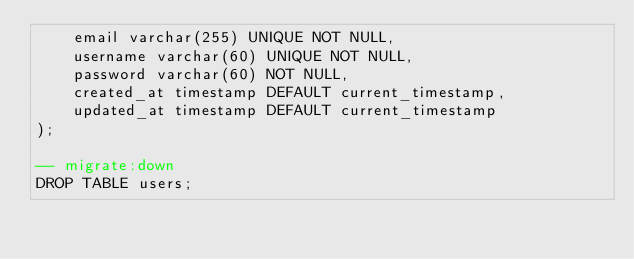Convert code to text. <code><loc_0><loc_0><loc_500><loc_500><_SQL_>	email varchar(255) UNIQUE NOT NULL,
	username varchar(60) UNIQUE NOT NULL,
	password varchar(60) NOT NULL,
	created_at timestamp DEFAULT current_timestamp,
	updated_at timestamp DEFAULT current_timestamp
);

-- migrate:down
DROP TABLE users;

</code> 